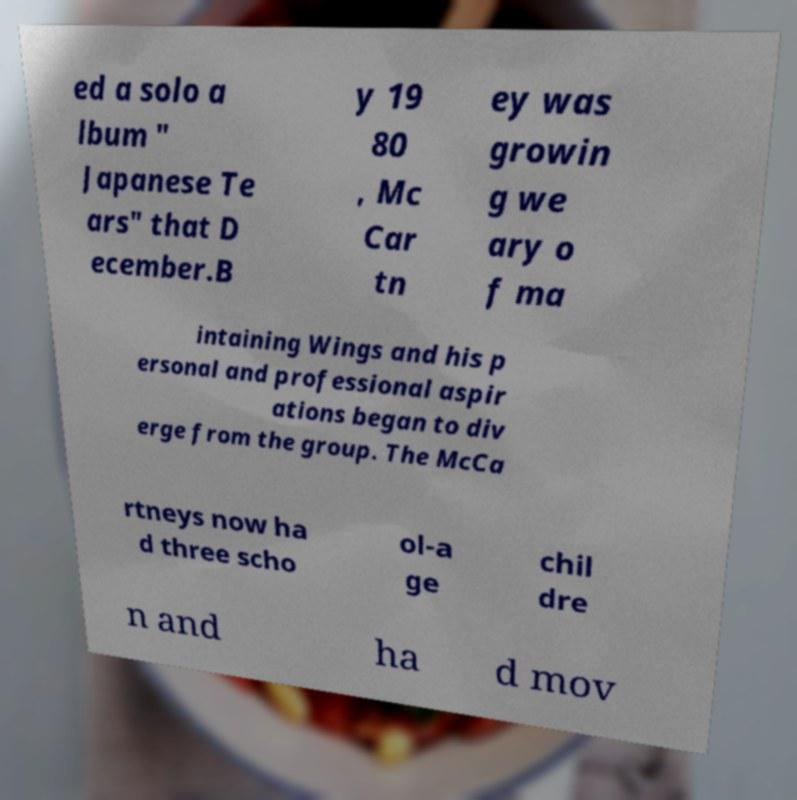Please identify and transcribe the text found in this image. ed a solo a lbum " Japanese Te ars" that D ecember.B y 19 80 , Mc Car tn ey was growin g we ary o f ma intaining Wings and his p ersonal and professional aspir ations began to div erge from the group. The McCa rtneys now ha d three scho ol-a ge chil dre n and ha d mov 